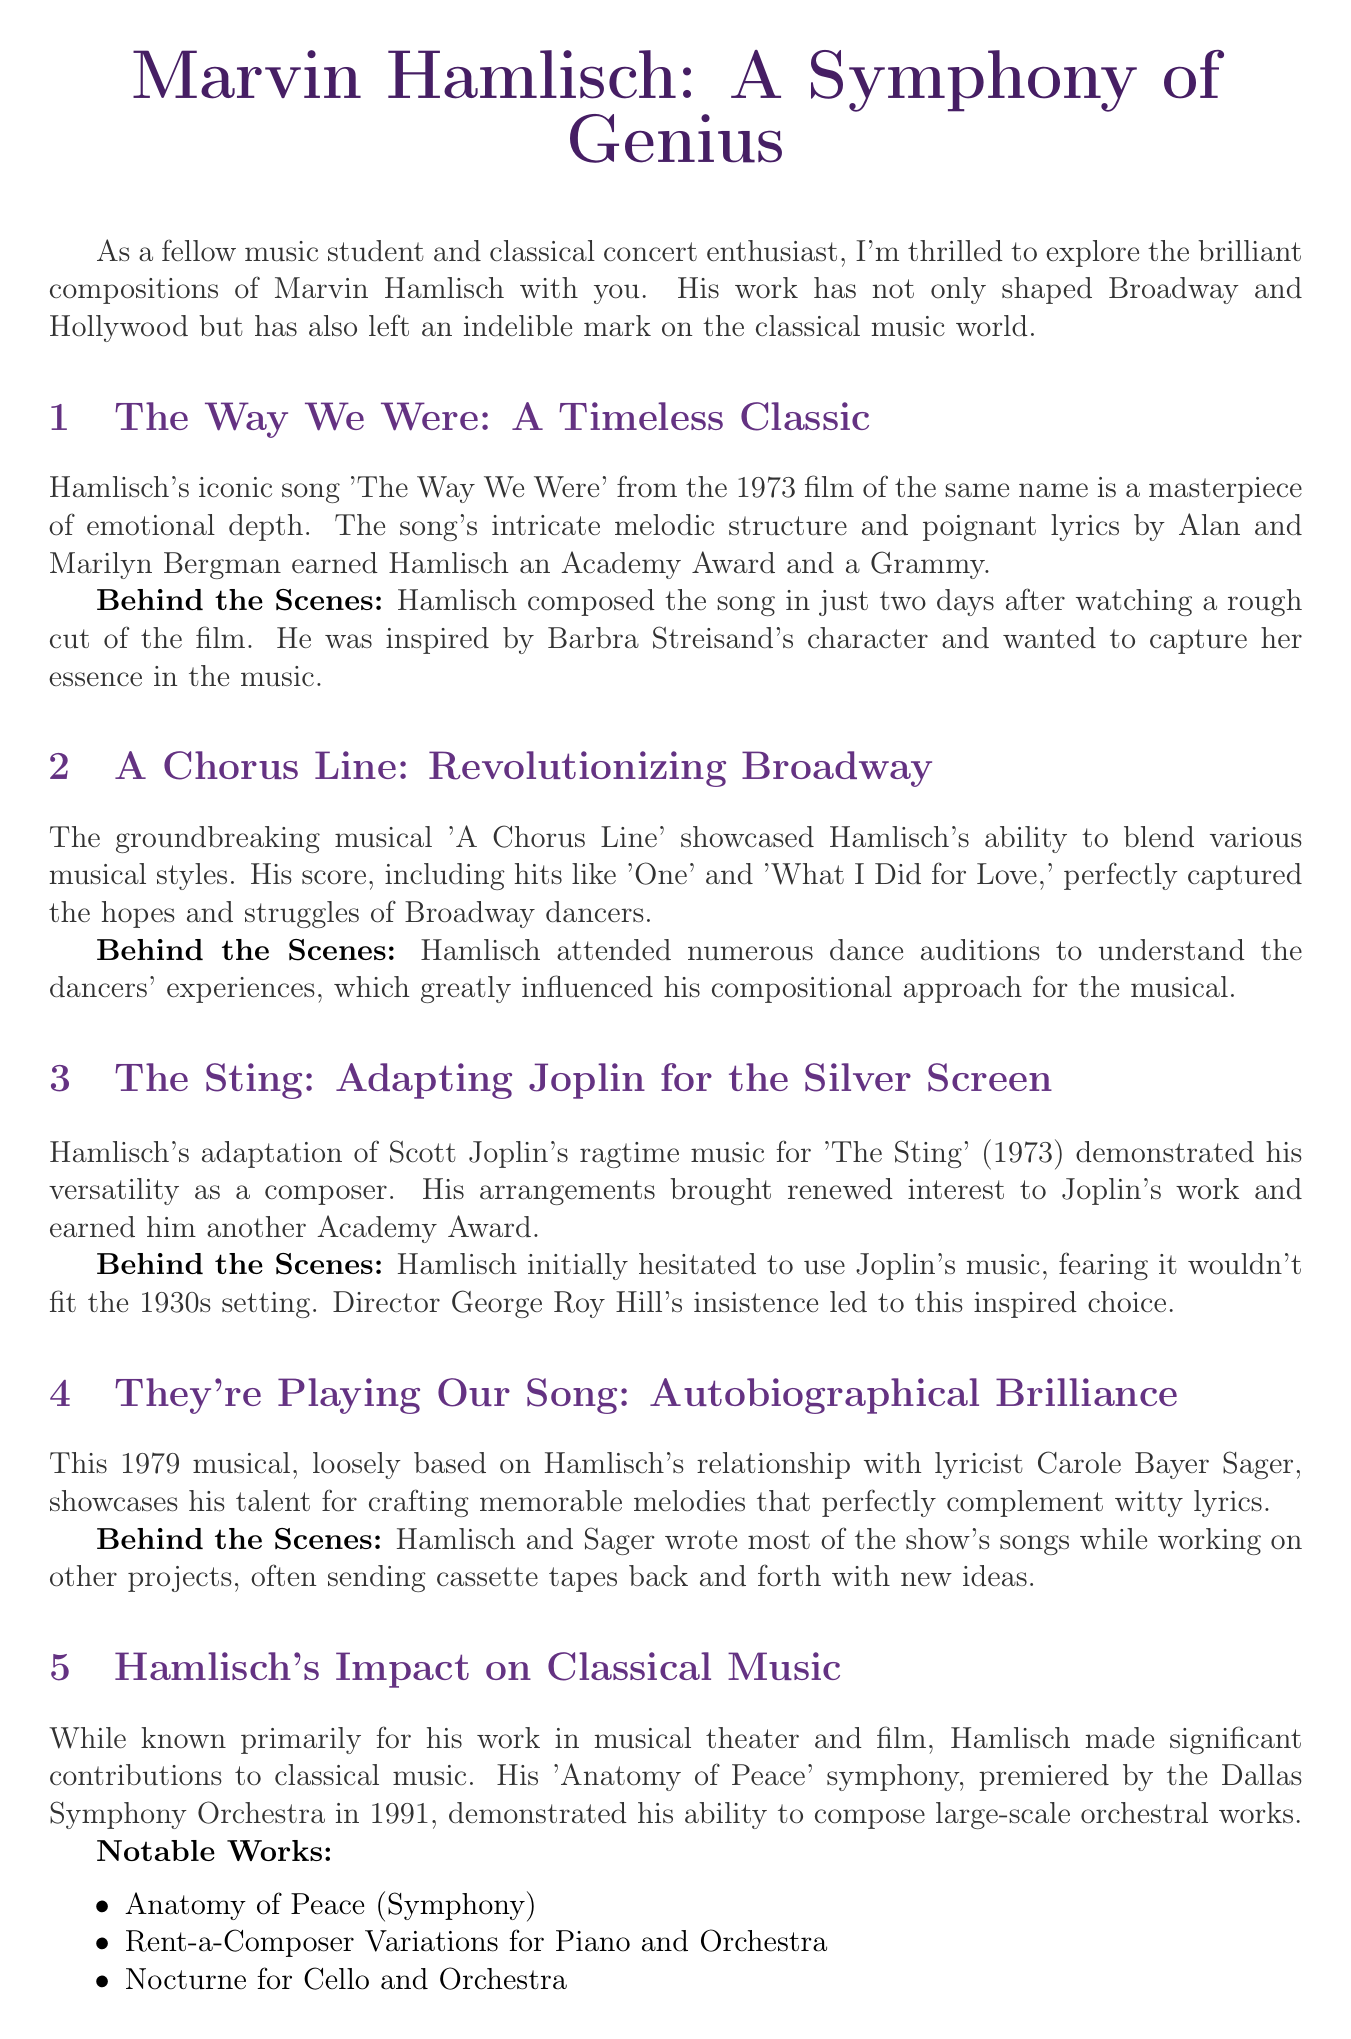What is the title of the newsletter? The title of the newsletter is mentioned at the beginning and serves as the main header of the document.
Answer: Marvin Hamlisch: A Symphony of Genius Who wrote the lyrics for "The Way We Were"? The lyrics of "The Way We Were" are credited to Alan and Marilyn Bergman, which is stated in the discussion of the song.
Answer: Alan and Marilyn Bergman What year was "A Chorus Line" released? The year of release for the musical "A Chorus Line" is noted in the content section, specifically stating its groundbreaking nature.
Answer: 1975 Which symphony was premiered by the Dallas Symphony Orchestra? The document provides information about Hamlisch's significant contribution to classical music, including this symphony's name.
Answer: Anatomy of Peace How many days did Hamlisch take to compose "The Way We Were"? This detail is included in the behind-the-scenes story for the song, indicating how quickly he worked after viewing the film.
Answer: Two days What event is scheduled for September 15, 2023? The events section lists upcoming events, making it clear which event takes place on that date.
Answer: Marvin Hamlisch Tribute Concert What musical is based on Hamlisch's relationship with Carole Bayer Sager? The document specifies this musical's connection to Hamlisch's personal experiences with Sager.
Answer: They're Playing Our Song Which film did Hamlisch adapt Joplin's music for? This is detailed in the section discussing Hamlisch's work in film, particularly his adaptation's notable recognition.
Answer: The Sting How many notable works are listed in the document's classical influence section? The section lists specific works attributed to Hamlisch, providing a count of the notable contributions.
Answer: Three 